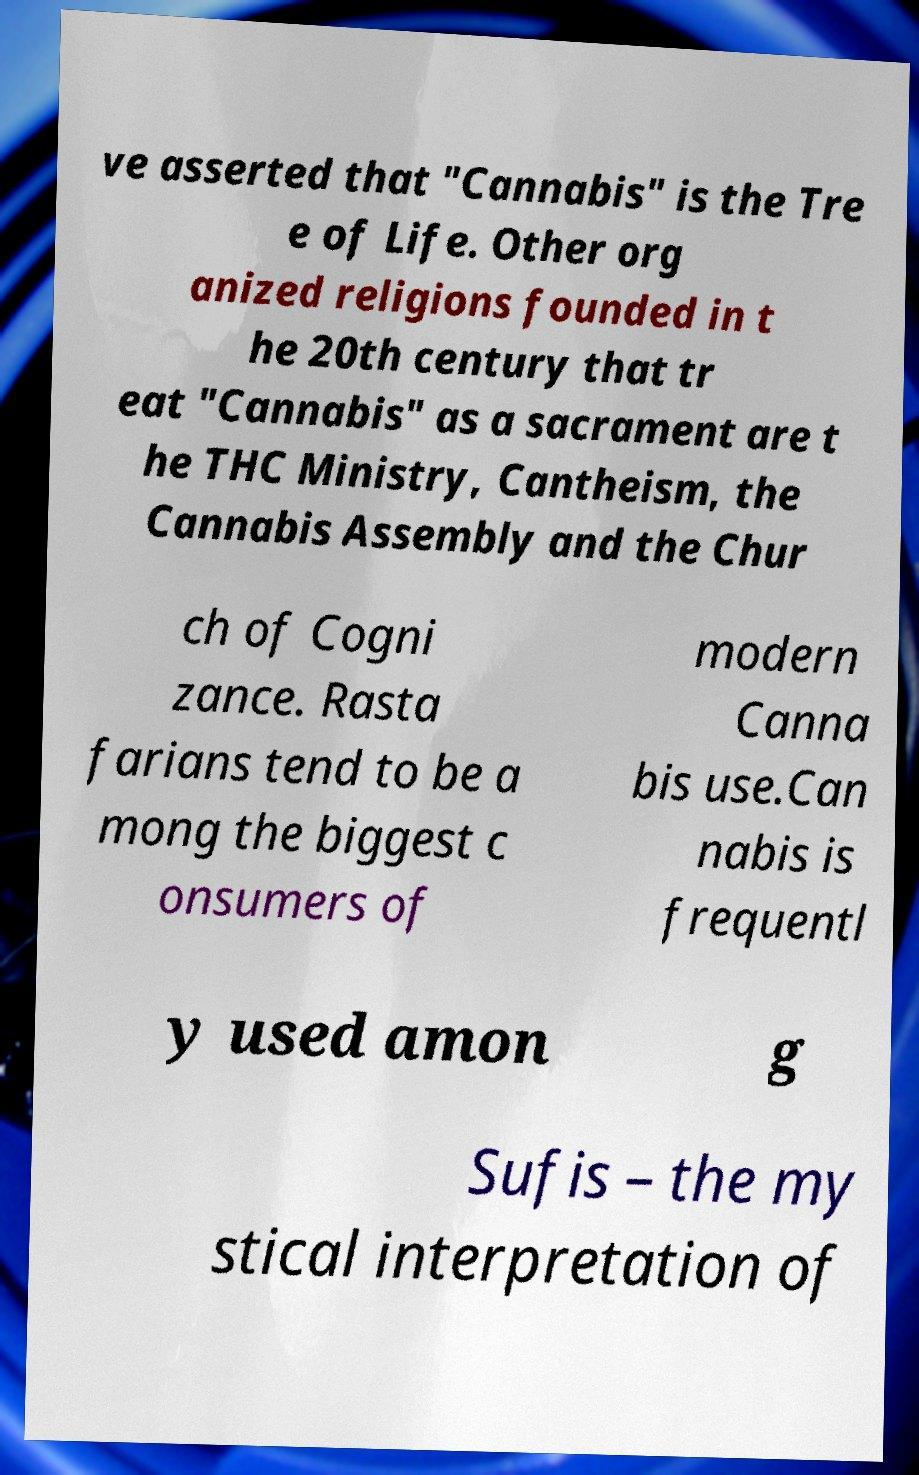What messages or text are displayed in this image? I need them in a readable, typed format. ve asserted that "Cannabis" is the Tre e of Life. Other org anized religions founded in t he 20th century that tr eat "Cannabis" as a sacrament are t he THC Ministry, Cantheism, the Cannabis Assembly and the Chur ch of Cogni zance. Rasta farians tend to be a mong the biggest c onsumers of modern Canna bis use.Can nabis is frequentl y used amon g Sufis – the my stical interpretation of 